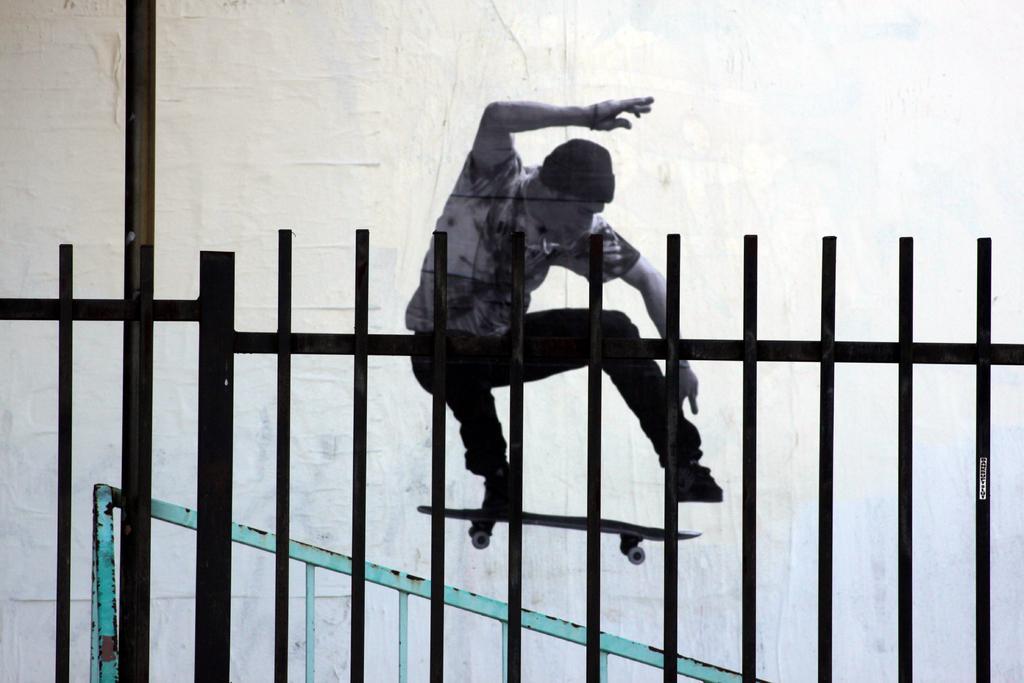Describe this image in one or two sentences. In this image we can see a metal fence. Behind it one man is doing skating. 